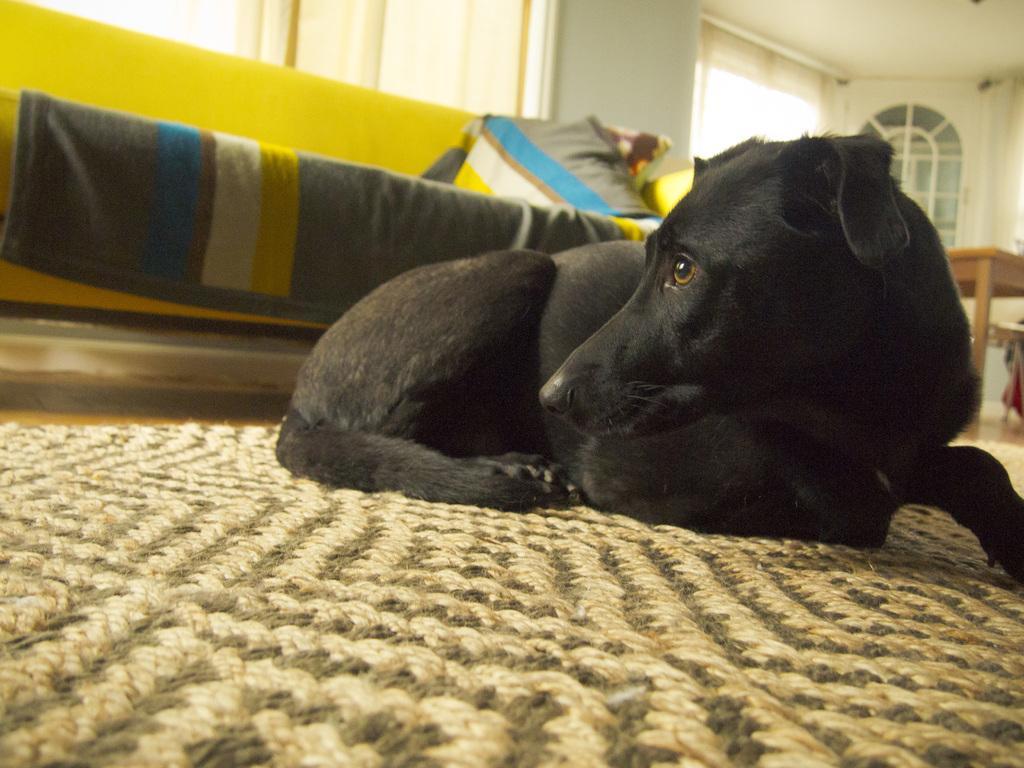Can you describe this image briefly? In the image there is a black dog laying on the mat floor with a sofa behind it with a table on the right side, in the back there is a door and a window on the wall. 